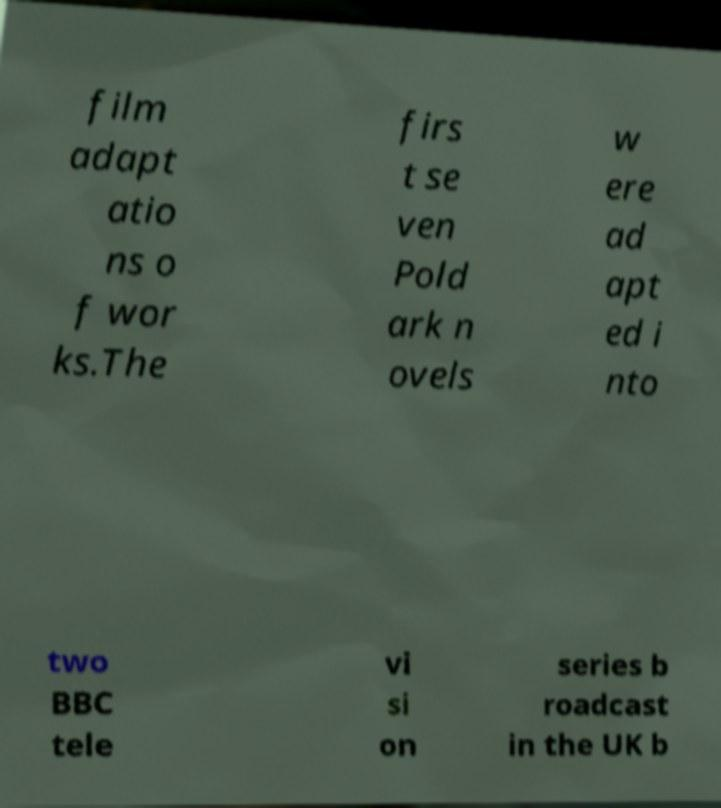What messages or text are displayed in this image? I need them in a readable, typed format. film adapt atio ns o f wor ks.The firs t se ven Pold ark n ovels w ere ad apt ed i nto two BBC tele vi si on series b roadcast in the UK b 